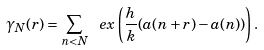Convert formula to latex. <formula><loc_0><loc_0><loc_500><loc_500>\gamma _ { N } ( r ) = \sum _ { n < N } \ e x \left ( \frac { h } { k } ( a ( n + r ) - a ( n ) ) \right ) .</formula> 